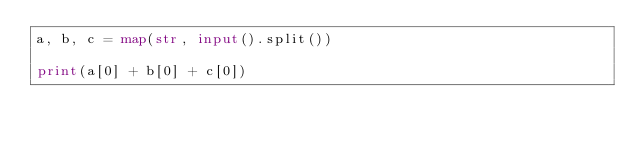<code> <loc_0><loc_0><loc_500><loc_500><_Python_>a, b, c = map(str, input().split())

print(a[0] + b[0] + c[0])</code> 